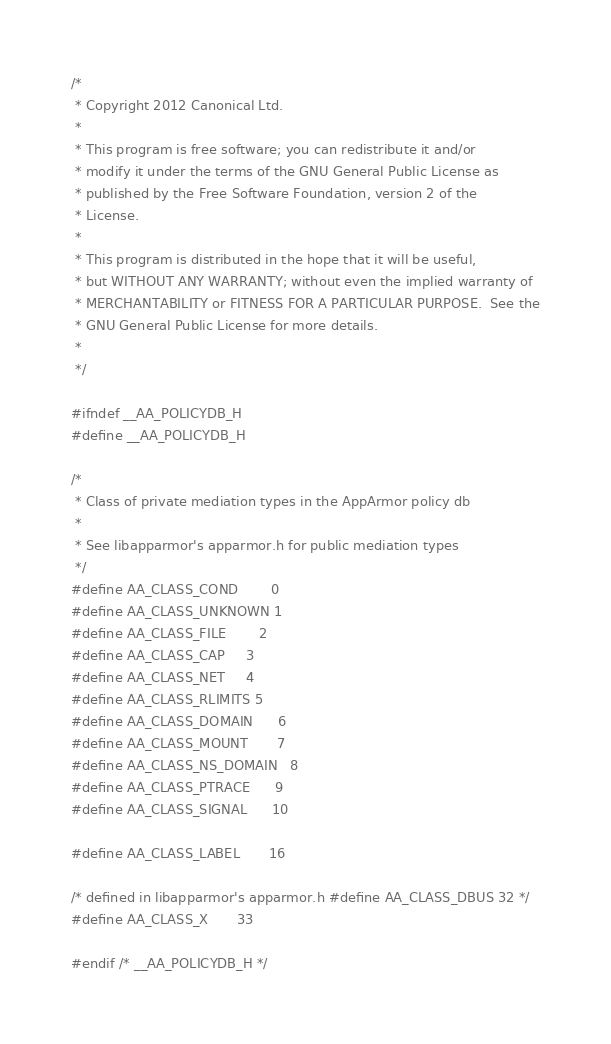<code> <loc_0><loc_0><loc_500><loc_500><_C_>/*
 * Copyright 2012 Canonical Ltd.
 *
 * This program is free software; you can redistribute it and/or
 * modify it under the terms of the GNU General Public License as
 * published by the Free Software Foundation, version 2 of the
 * License.
 *
 * This program is distributed in the hope that it will be useful,
 * but WITHOUT ANY WARRANTY; without even the implied warranty of
 * MERCHANTABILITY or FITNESS FOR A PARTICULAR PURPOSE.  See the
 * GNU General Public License for more details.
 *
 */

#ifndef __AA_POLICYDB_H
#define __AA_POLICYDB_H

/*
 * Class of private mediation types in the AppArmor policy db
 *
 * See libapparmor's apparmor.h for public mediation types
 */
#define AA_CLASS_COND		0
#define AA_CLASS_UNKNOWN	1
#define AA_CLASS_FILE		2
#define AA_CLASS_CAP		3
#define AA_CLASS_NET		4
#define AA_CLASS_RLIMITS	5
#define AA_CLASS_DOMAIN		6
#define AA_CLASS_MOUNT		7
#define AA_CLASS_NS_DOMAIN	8
#define AA_CLASS_PTRACE		9
#define AA_CLASS_SIGNAL		10

#define AA_CLASS_LABEL		16

/* defined in libapparmor's apparmor.h #define AA_CLASS_DBUS 32 */
#define AA_CLASS_X		33

#endif /* __AA_POLICYDB_H */
</code> 